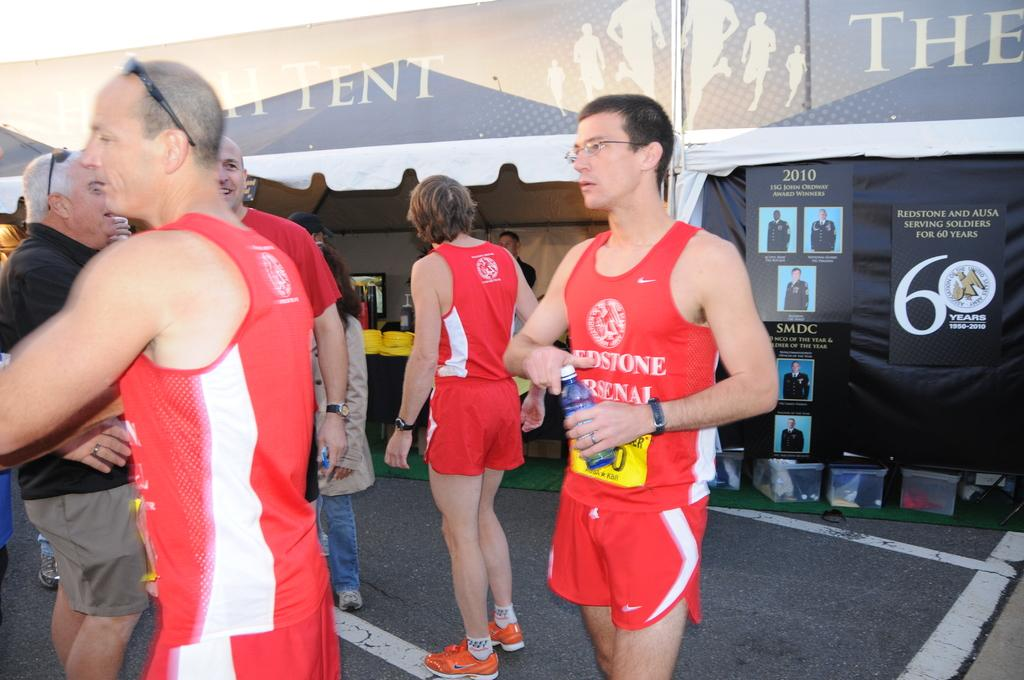Provide a one-sentence caption for the provided image. a man wearing a redstone arsenol shirt with water. 